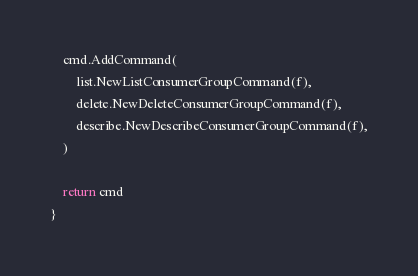Convert code to text. <code><loc_0><loc_0><loc_500><loc_500><_Go_>	cmd.AddCommand(
		list.NewListConsumerGroupCommand(f),
		delete.NewDeleteConsumerGroupCommand(f),
		describe.NewDescribeConsumerGroupCommand(f),
	)

	return cmd
}
</code> 